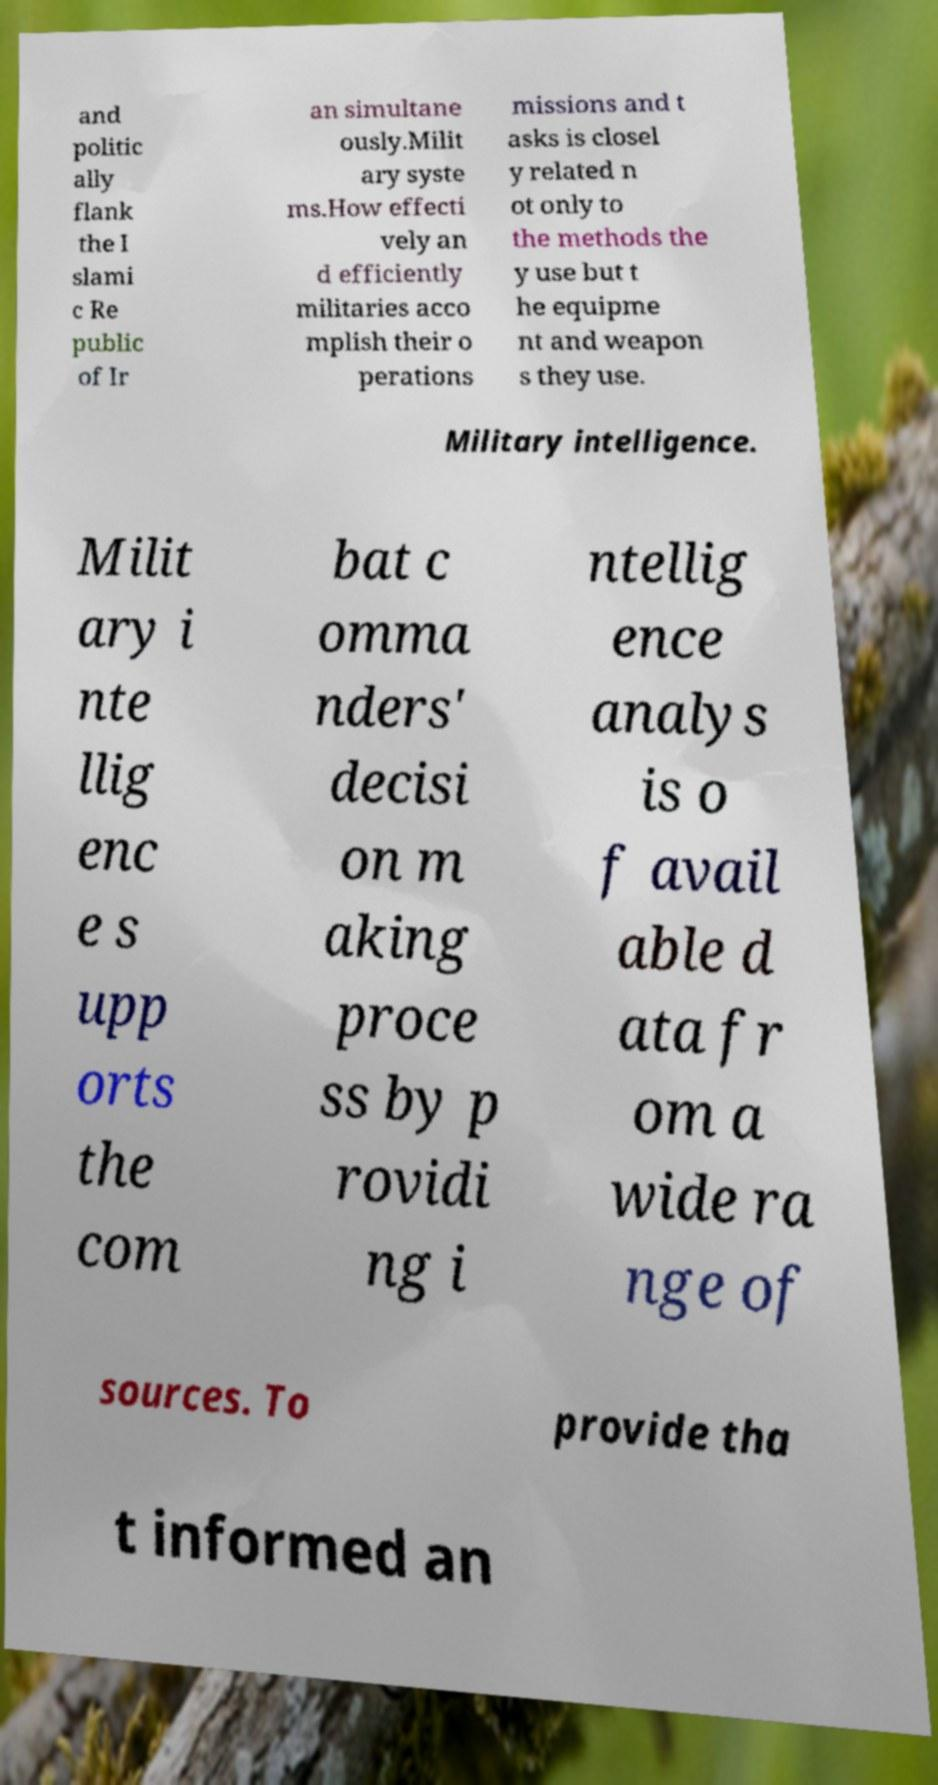Can you read and provide the text displayed in the image?This photo seems to have some interesting text. Can you extract and type it out for me? and politic ally flank the I slami c Re public of Ir an simultane ously.Milit ary syste ms.How effecti vely an d efficiently militaries acco mplish their o perations missions and t asks is closel y related n ot only to the methods the y use but t he equipme nt and weapon s they use. Military intelligence. Milit ary i nte llig enc e s upp orts the com bat c omma nders' decisi on m aking proce ss by p rovidi ng i ntellig ence analys is o f avail able d ata fr om a wide ra nge of sources. To provide tha t informed an 